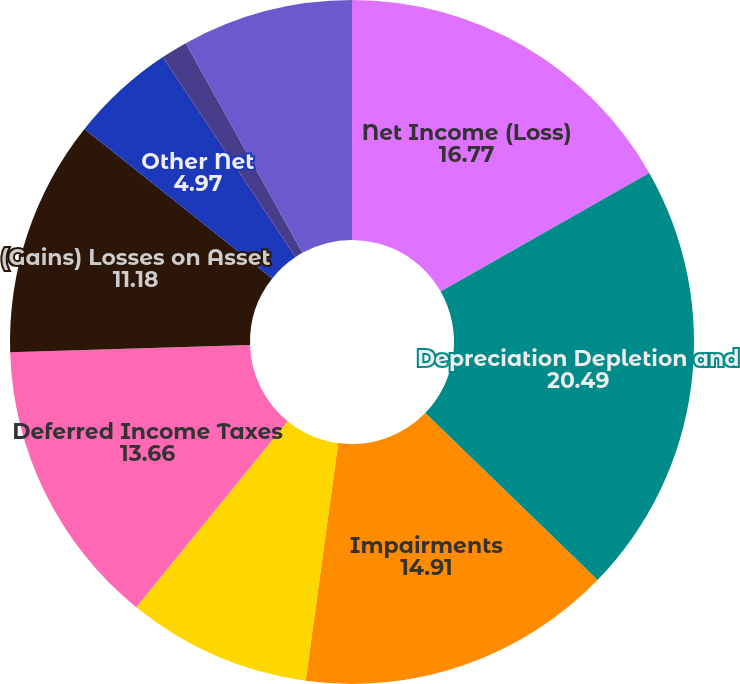Convert chart to OTSL. <chart><loc_0><loc_0><loc_500><loc_500><pie_chart><fcel>Year Ended December 31<fcel>Net Income (Loss)<fcel>Depreciation Depletion and<fcel>Impairments<fcel>Stock-Based Compensation<fcel>Deferred Income Taxes<fcel>(Gains) Losses on Asset<fcel>Other Net<fcel>Dry Hole Costs<fcel>Total (Gains) Losses<nl><fcel>0.0%<fcel>16.77%<fcel>20.49%<fcel>14.91%<fcel>8.7%<fcel>13.66%<fcel>11.18%<fcel>4.97%<fcel>1.25%<fcel>8.08%<nl></chart> 